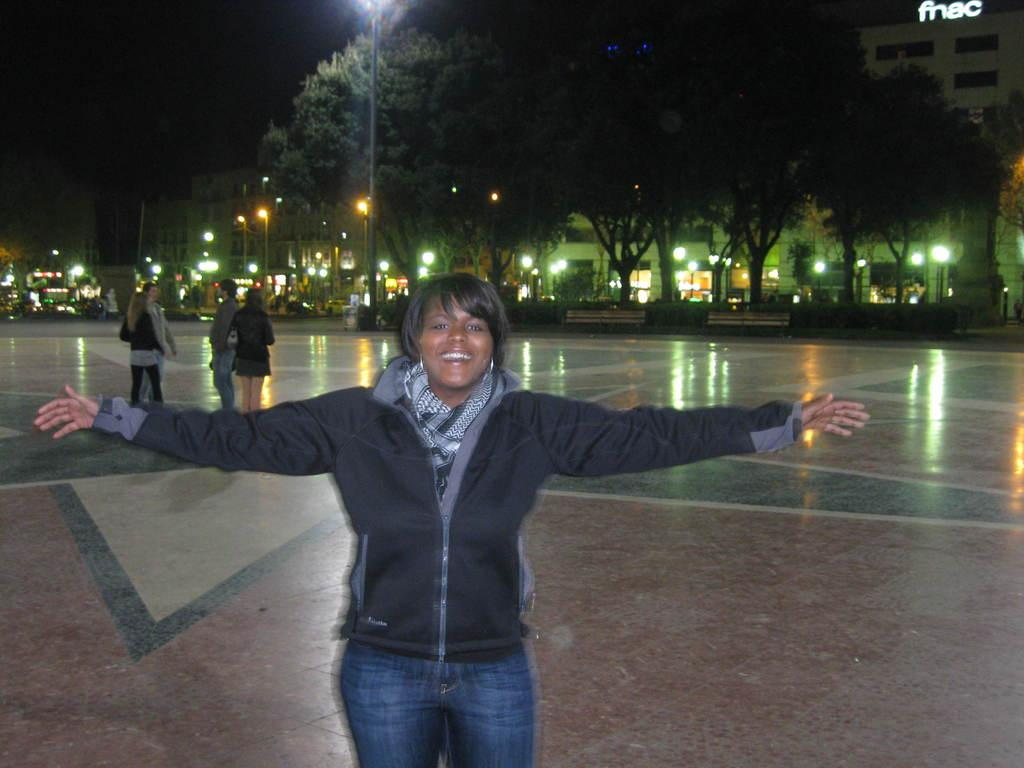Who is the main subject in the image? There is a woman in the image. What is the woman doing in the image? The woman is standing. What is the woman wearing in the image? The woman is wearing a black coat. What can be seen in the background of the image? There are people, poles, lights, trees, and buildings in the background of the image. What is the title of the book the man is holding in the image? There is no man present in the image, and therefore no book or title can be observed. 